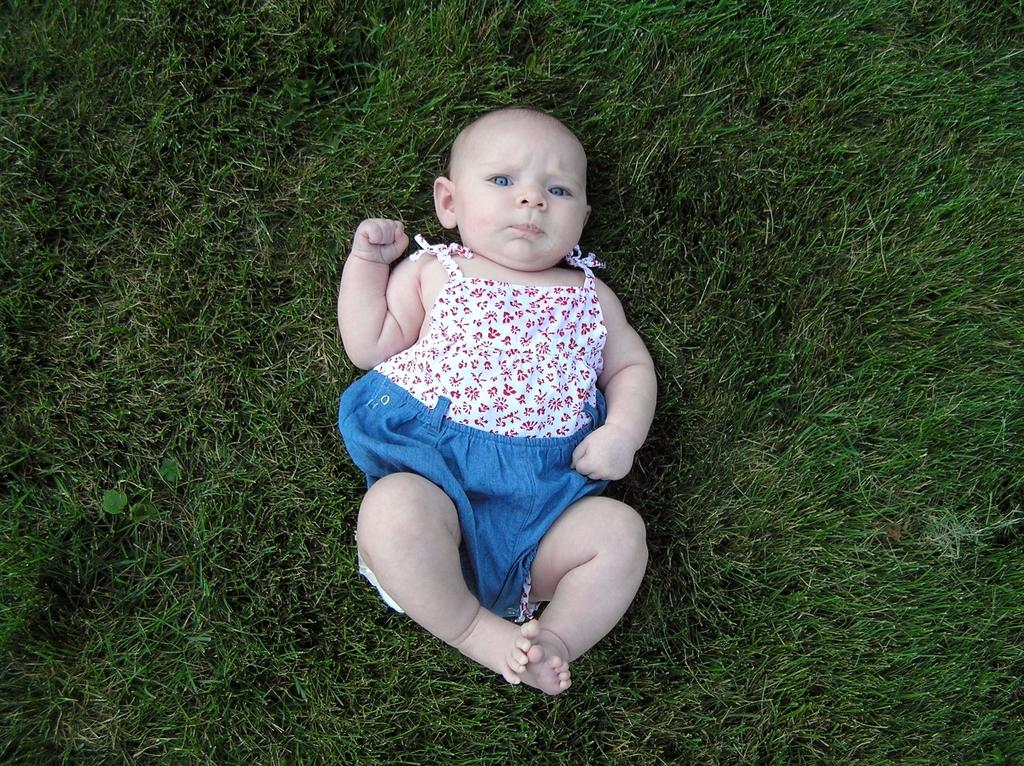What type of vegetation is visible in the image? There is grass in the image. What else can be seen in the image besides the grass? There is a baby in the image. What is the baby wearing? The baby is wearing a white and blue color dress. What type of poison is the baby holding in the image? There is no poison present in the image; the baby is wearing a white and blue color dress. What is the acoustics like in the image? The provided facts do not give any information about the acoustics in the image. 